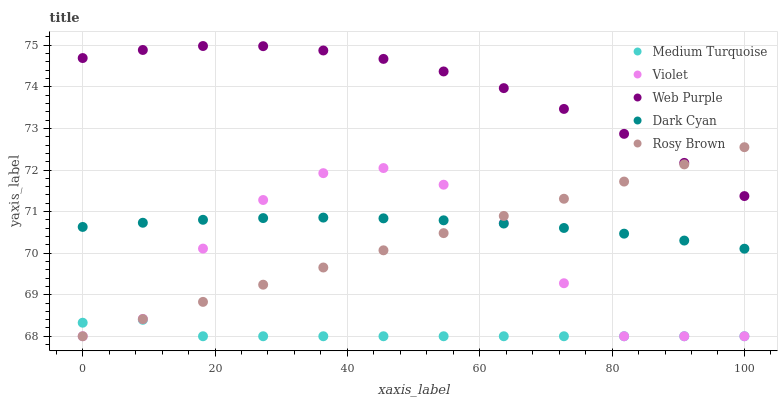Does Medium Turquoise have the minimum area under the curve?
Answer yes or no. Yes. Does Web Purple have the maximum area under the curve?
Answer yes or no. Yes. Does Rosy Brown have the minimum area under the curve?
Answer yes or no. No. Does Rosy Brown have the maximum area under the curve?
Answer yes or no. No. Is Rosy Brown the smoothest?
Answer yes or no. Yes. Is Violet the roughest?
Answer yes or no. Yes. Is Web Purple the smoothest?
Answer yes or no. No. Is Web Purple the roughest?
Answer yes or no. No. Does Rosy Brown have the lowest value?
Answer yes or no. Yes. Does Web Purple have the lowest value?
Answer yes or no. No. Does Web Purple have the highest value?
Answer yes or no. Yes. Does Rosy Brown have the highest value?
Answer yes or no. No. Is Medium Turquoise less than Web Purple?
Answer yes or no. Yes. Is Web Purple greater than Dark Cyan?
Answer yes or no. Yes. Does Violet intersect Medium Turquoise?
Answer yes or no. Yes. Is Violet less than Medium Turquoise?
Answer yes or no. No. Is Violet greater than Medium Turquoise?
Answer yes or no. No. Does Medium Turquoise intersect Web Purple?
Answer yes or no. No. 